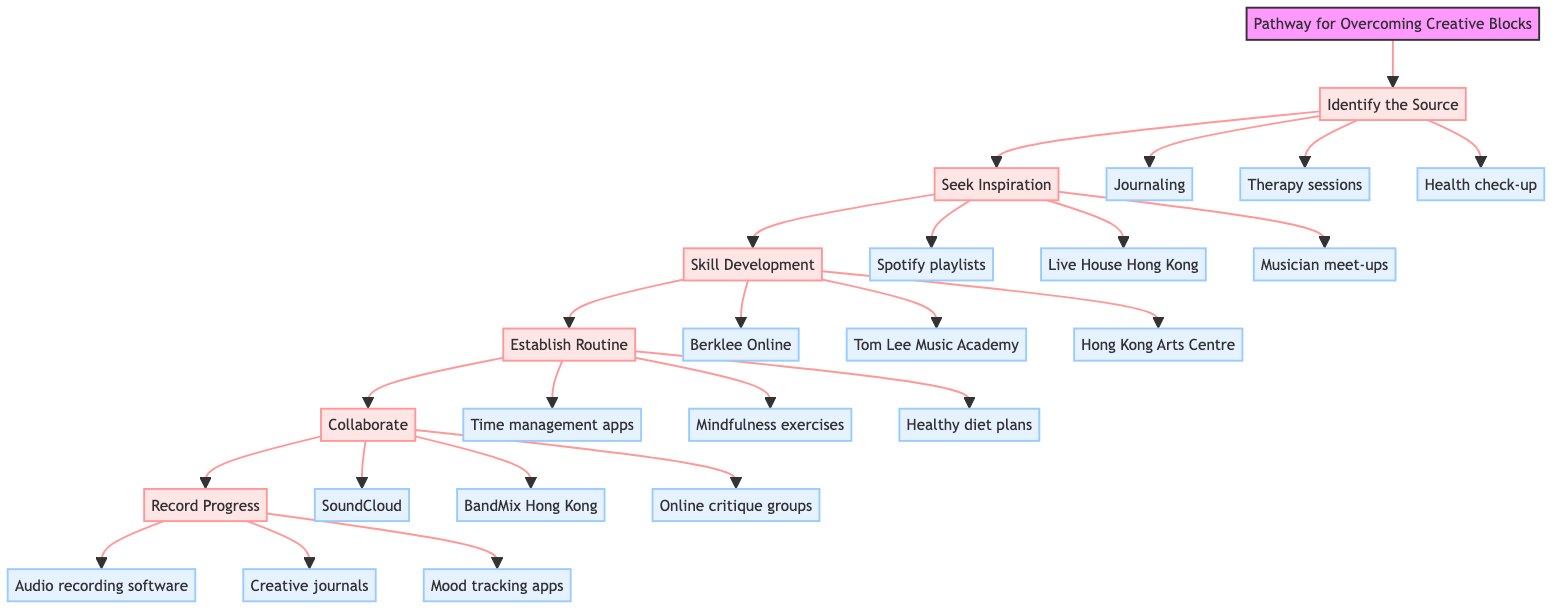What is the first step in the pathway? The first step outlined in the diagram is "Identify the Source," which is presented directly as the starting point of the pathway.
Answer: Identify the Source How many main steps are there in the pathway? By counting the major steps listed in the diagram, there are a total of six main steps.
Answer: 6 What resource is associated with the "Seek Inspiration" step? The resources linked to "Seek Inspiration" include three options: Spotify playlists, Live House Hong Kong, and Musician meet-up groups. One example can be directly referenced as a resource associated with this step.
Answer: Spotify playlists Which step comes after "Skill Development"? Following the "Skill Development" step in sequential flow is the "Establish Routine" step, maintaining the continuity of the pathway.
Answer: Establish Routine What type of resource is "Audio recording software"? "Audio recording software" is listed as a resource linked to the final step of "Record Progress," identifying it specifically as a resource for creativity documentation.
Answer: Resource Name a mentor type mentioned in the support section. The support section of the diagram lists three types of mentors, one of which is "Local music teachers," directly identifiable from the diagram's information.
Answer: Local music teachers What is the last step in the pathway? The last step in the clinical pathway diagram is labeled "Record Progress," marking the endpoint of the outlined steps to overcome creative blocks.
Answer: Record Progress What is the connection between "Collaborate" and "Record Progress"? The relationship outlines a sequential connection where "Collaborate" is followed by "Record Progress," indicating that collaboration is a precursor to recording creative achievements.
Answer: Sequential connection How many components are listed under "Establish Routine"? Under the "Establish Routine" step, three components are provided, highlighting specific actions to maintain a routine.
Answer: 3 